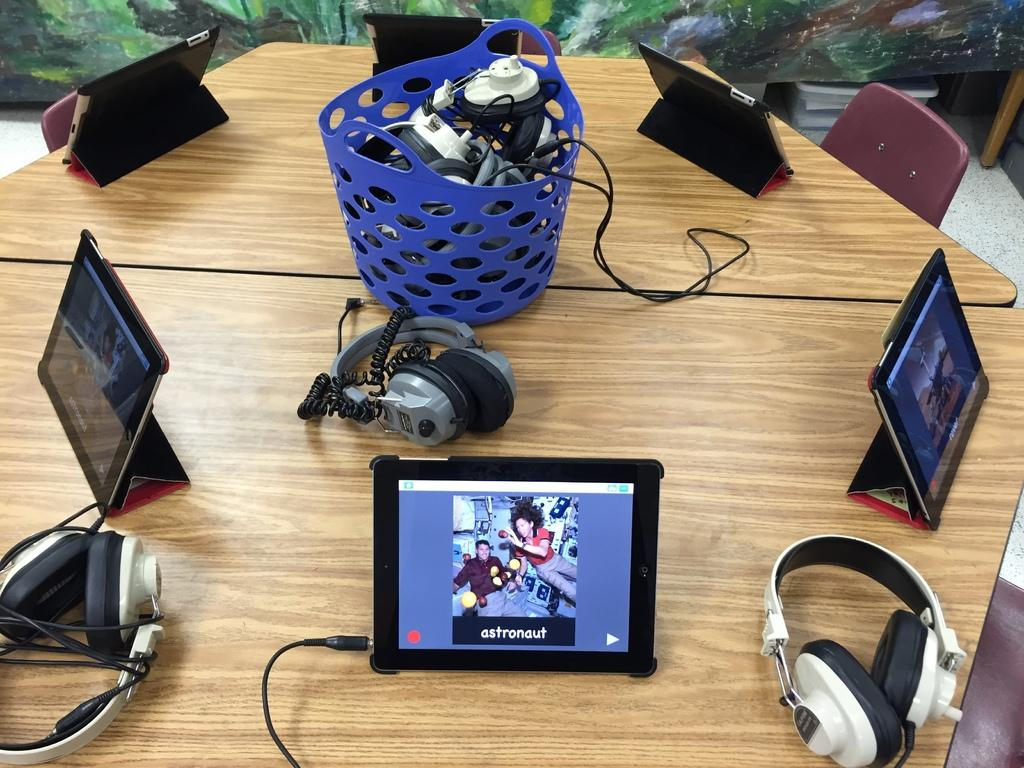What piece of furniture is present in the image? There is a table in the image. What is on top of the table? There is a basket on the table. What items are inside the basket? The basket contains cables and headphones. What type of seating is visible in the image? There are tables and chairs visible in the image. Is there a doctor in the image rubbing powder on the table? No, there is no doctor present in the image, and no one is rubbing powder on the table. 